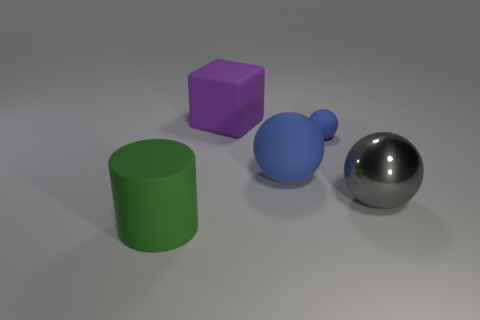Add 4 tiny blue objects. How many objects exist? 9 Subtract 0 red cubes. How many objects are left? 5 Subtract all cylinders. How many objects are left? 4 Subtract 1 blocks. How many blocks are left? 0 Subtract all cyan spheres. Subtract all cyan blocks. How many spheres are left? 3 Subtract all yellow blocks. How many brown spheres are left? 0 Subtract all large purple metal blocks. Subtract all green rubber cylinders. How many objects are left? 4 Add 5 gray metallic balls. How many gray metallic balls are left? 6 Add 1 big red shiny cylinders. How many big red shiny cylinders exist? 1 Subtract all blue spheres. How many spheres are left? 1 